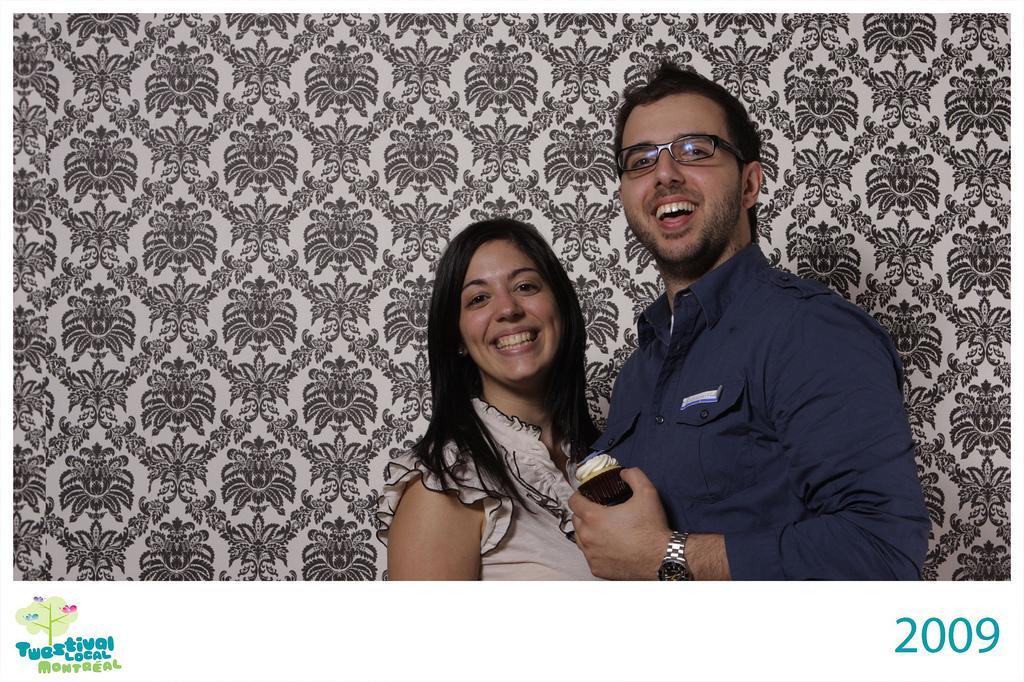Could you give a brief overview of what you see in this image? In this image we can see two persons with smiling faces standing, one man with spectacles holding an object, there is the designed background looks like a curtain, some numbers on the bottom right side corner of the image and some text with an image on the bottom left side corner of the image. 